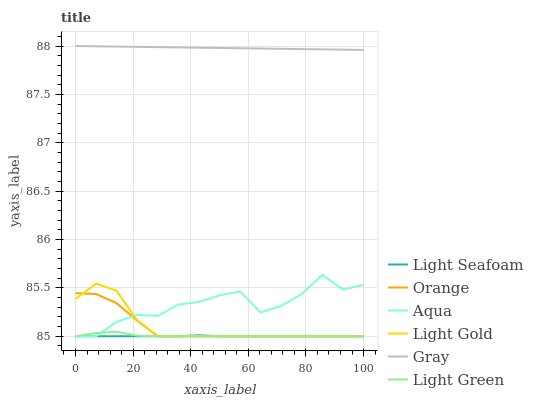Does Light Seafoam have the minimum area under the curve?
Answer yes or no. Yes. Does Gray have the maximum area under the curve?
Answer yes or no. Yes. Does Aqua have the minimum area under the curve?
Answer yes or no. No. Does Aqua have the maximum area under the curve?
Answer yes or no. No. Is Gray the smoothest?
Answer yes or no. Yes. Is Aqua the roughest?
Answer yes or no. Yes. Is Light Green the smoothest?
Answer yes or no. No. Is Light Green the roughest?
Answer yes or no. No. Does Aqua have the lowest value?
Answer yes or no. Yes. Does Gray have the highest value?
Answer yes or no. Yes. Does Aqua have the highest value?
Answer yes or no. No. Is Orange less than Gray?
Answer yes or no. Yes. Is Gray greater than Orange?
Answer yes or no. Yes. Does Aqua intersect Orange?
Answer yes or no. Yes. Is Aqua less than Orange?
Answer yes or no. No. Is Aqua greater than Orange?
Answer yes or no. No. Does Orange intersect Gray?
Answer yes or no. No. 